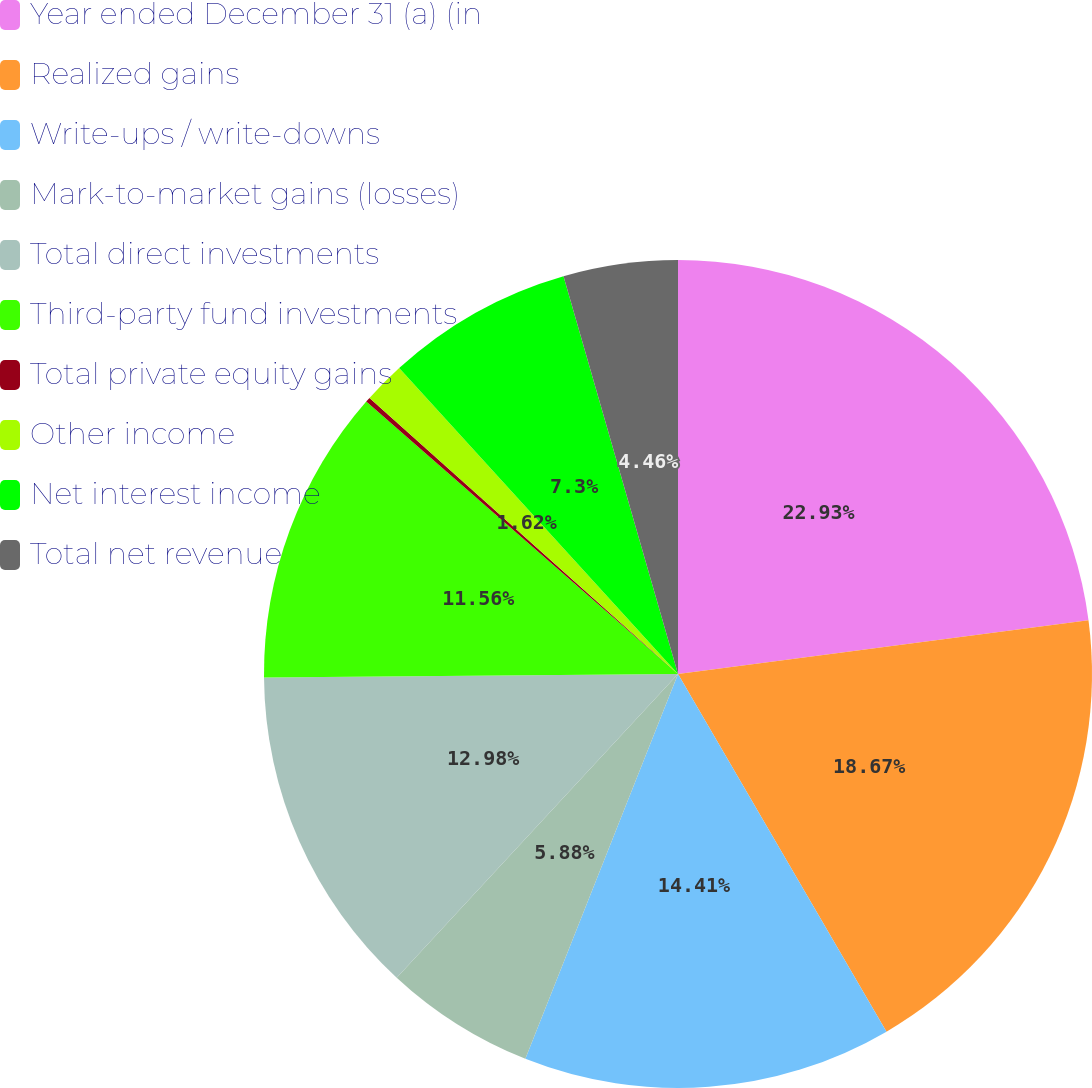<chart> <loc_0><loc_0><loc_500><loc_500><pie_chart><fcel>Year ended December 31 (a) (in<fcel>Realized gains<fcel>Write-ups / write-downs<fcel>Mark-to-market gains (losses)<fcel>Total direct investments<fcel>Third-party fund investments<fcel>Total private equity gains<fcel>Other income<fcel>Net interest income<fcel>Total net revenue<nl><fcel>22.93%<fcel>18.67%<fcel>14.41%<fcel>5.88%<fcel>12.98%<fcel>11.56%<fcel>0.19%<fcel>1.62%<fcel>7.3%<fcel>4.46%<nl></chart> 